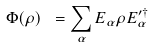<formula> <loc_0><loc_0><loc_500><loc_500>\Phi ( \rho ) \text { } = \sum _ { \alpha } E _ { \alpha } \rho E _ { \alpha } ^ { \prime \dagger }</formula> 